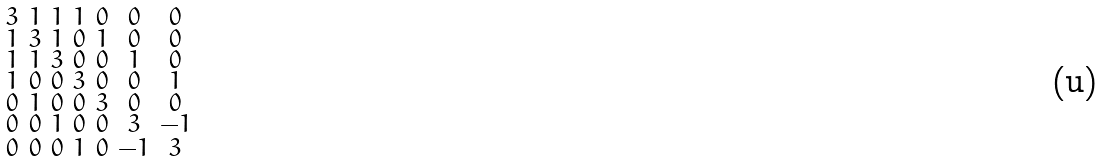Convert formula to latex. <formula><loc_0><loc_0><loc_500><loc_500>\begin{smallmatrix} 3 & 1 & 1 & 1 & 0 & 0 & 0 \\ 1 & 3 & 1 & 0 & 1 & 0 & 0 \\ 1 & 1 & 3 & 0 & 0 & 1 & 0 \\ 1 & 0 & 0 & 3 & 0 & 0 & 1 \\ 0 & 1 & 0 & 0 & 3 & 0 & 0 \\ 0 & 0 & 1 & 0 & 0 & 3 & - 1 \\ 0 & 0 & 0 & 1 & 0 & - 1 & 3 \end{smallmatrix}</formula> 